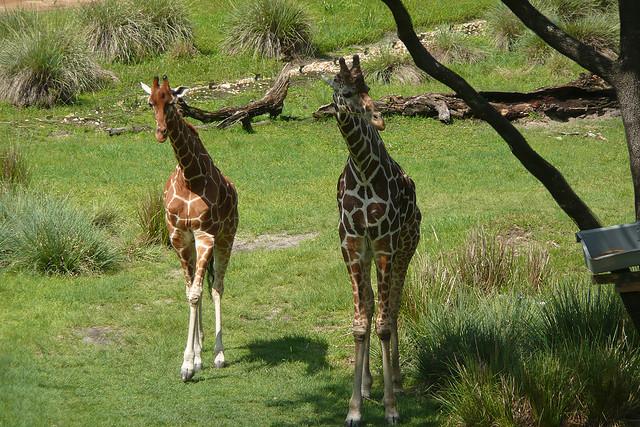Are there any plants on the ground?
Be succinct. Yes. What time of day is it?
Give a very brief answer. Afternoon. Are these two giraffe standing in the shade?
Answer briefly. No. 